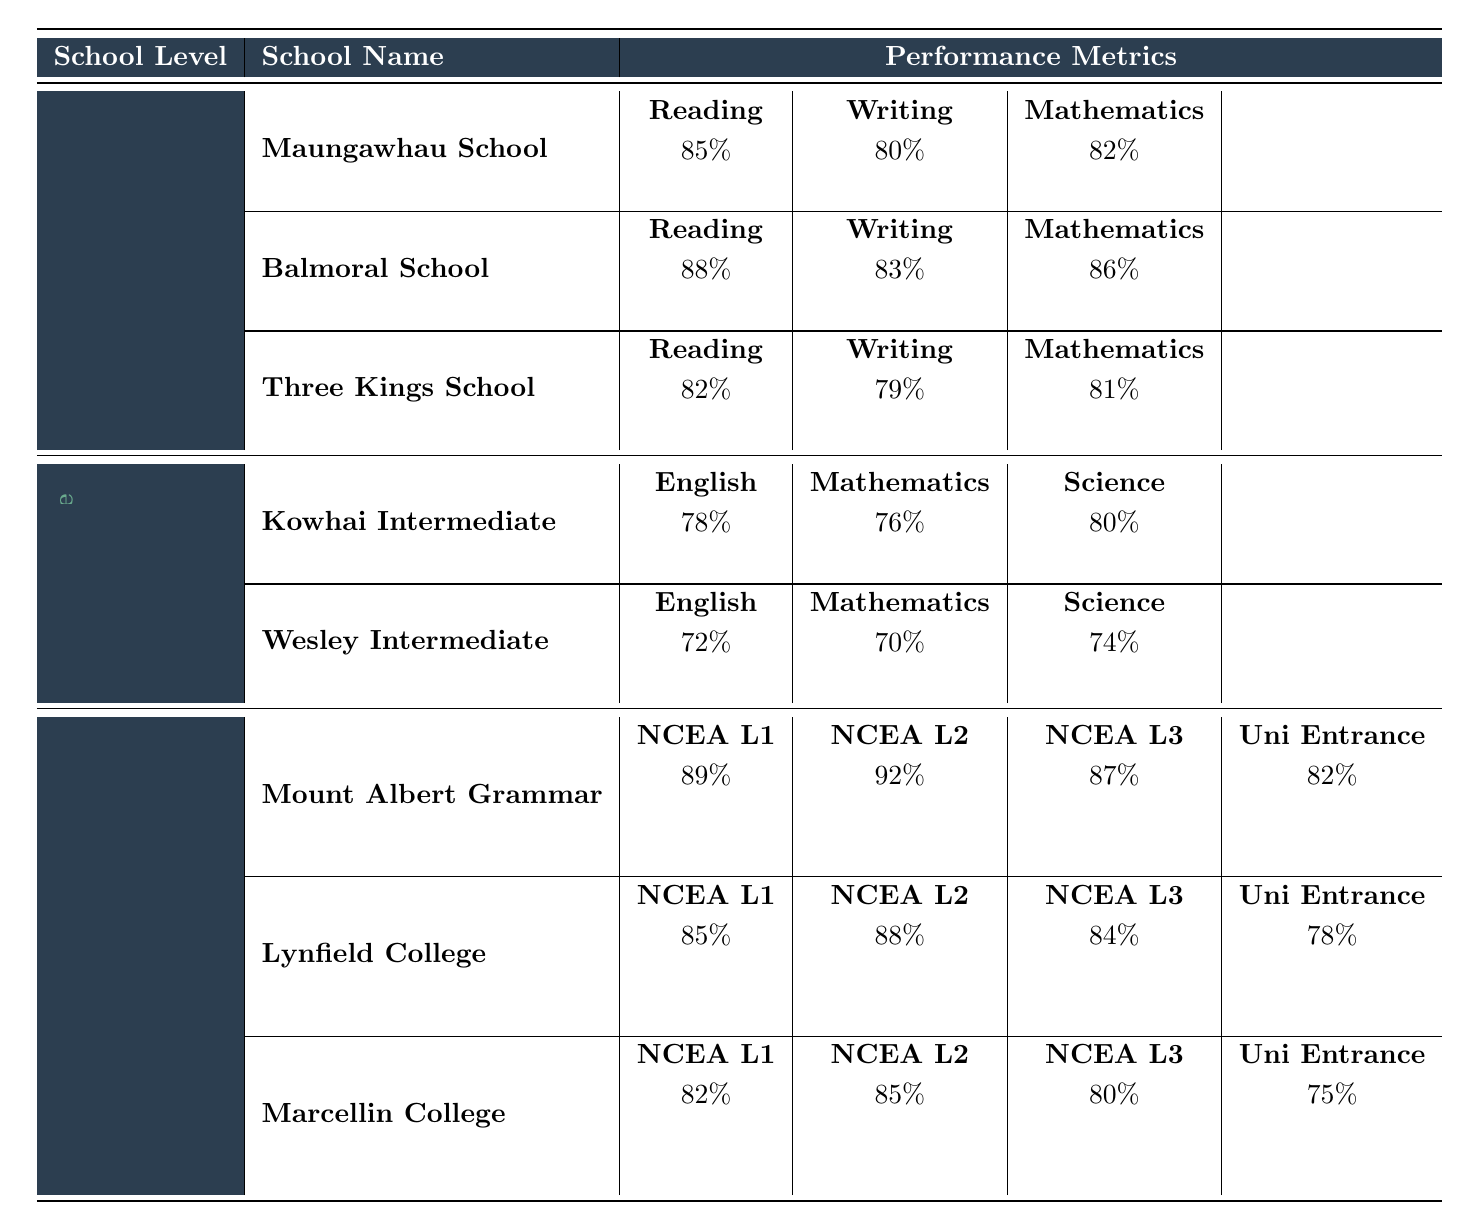What is the reading score for Balmoral School? The table shows that Balmoral School has a reading score of 88%.
Answer: 88% Which school has the highest writing score among primary schools? Looking at the writing scores for the primary schools, Balmoral School has the highest score at 83%.
Answer: Balmoral School What is the average mathematics score for primary schools? The mathematics scores for the primary schools are 82% (Maungawhau School), 86% (Balmoral School), and 81% (Three Kings School). The average is (82 + 86 + 81) / 3 = 83%.
Answer: 83% Did Wesley Intermediate achieve more than 75% in Science? Wesley Intermediate has a science score of 74%, which is less than 75%.
Answer: No Which secondary school has the lowest University Entrance score? The University Entrance scores are 82% for Mount Albert Grammar, 78% for Lynfield College, and 75% for Marcellin College. Marcellin College has the lowest score at 75%.
Answer: Marcellin College What is the total score for NCEA Level 1 across all secondary schools? The NCEA Level 1 scores are 89% (Mount Albert Grammar), 85% (Lynfield College), and 82% (Marcellin College). Adding them gives 89 + 85 + 82 = 256%.
Answer: 256% Is the average English score for intermediate schools above 75%? Kowhai Intermediate has an English score of 78% and Wesley Intermediate has 72%. The average is (78 + 72) / 2 = 75%. The average is not above 75%.
Answer: No Which primary school had the lowest overall performance across Reading, Writing, and Mathematics? The overall scores are 85% (Maungawhau), 88% (Balmoral), and 82% (Three Kings) for reading, 80% (Maungawhau), 83% (Balmoral), and 79% (Three Kings) for writing, and 82% (Maungawhau), 86% (Balmoral), and 81% (Three Kings) for mathematics. Three Kings School has the lowest combined performance.
Answer: Three Kings School What is the difference between the highest and lowest NCEA Level 3 scores? Mount Albert Grammar has the highest NCEA Level 3 score of 87% and Marcellin College has the lowest score of 80%. The difference is 87 - 80 = 7%.
Answer: 7% Which school has the highest score in Mathematics among intermediate schools? Kowhai Intermediate has a Mathematics score of 76%, and Wesley Intermediate has a score of 70%. Kowhai Intermediate has the highest score.
Answer: Kowhai Intermediate 